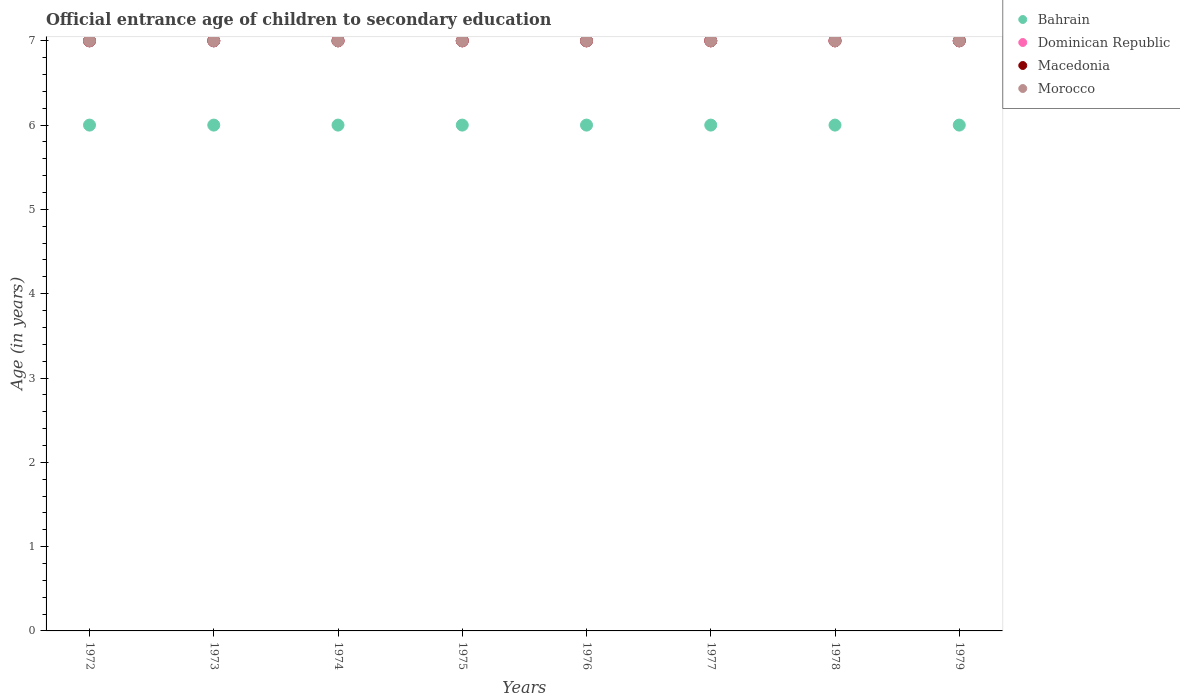Is the number of dotlines equal to the number of legend labels?
Your answer should be compact. Yes. What is the secondary school starting age of children in Dominican Republic in 1979?
Offer a terse response. 7. In which year was the secondary school starting age of children in Macedonia minimum?
Your answer should be very brief. 1972. What is the total secondary school starting age of children in Dominican Republic in the graph?
Ensure brevity in your answer.  56. What is the difference between the secondary school starting age of children in Bahrain in 1976 and that in 1978?
Provide a short and direct response. 0. What is the difference between the secondary school starting age of children in Dominican Republic in 1973 and the secondary school starting age of children in Macedonia in 1972?
Your answer should be compact. 0. What is the average secondary school starting age of children in Dominican Republic per year?
Make the answer very short. 7. In the year 1973, what is the difference between the secondary school starting age of children in Dominican Republic and secondary school starting age of children in Macedonia?
Provide a succinct answer. 0. What is the ratio of the secondary school starting age of children in Morocco in 1974 to that in 1979?
Offer a very short reply. 1. Is the secondary school starting age of children in Dominican Republic in 1978 less than that in 1979?
Provide a short and direct response. No. Is the difference between the secondary school starting age of children in Dominican Republic in 1972 and 1978 greater than the difference between the secondary school starting age of children in Macedonia in 1972 and 1978?
Give a very brief answer. No. What is the difference between the highest and the second highest secondary school starting age of children in Macedonia?
Make the answer very short. 0. Is it the case that in every year, the sum of the secondary school starting age of children in Bahrain and secondary school starting age of children in Morocco  is greater than the secondary school starting age of children in Macedonia?
Your answer should be compact. Yes. Is the secondary school starting age of children in Dominican Republic strictly greater than the secondary school starting age of children in Bahrain over the years?
Provide a short and direct response. Yes. How many dotlines are there?
Offer a terse response. 4. Does the graph contain any zero values?
Make the answer very short. No. Where does the legend appear in the graph?
Provide a short and direct response. Top right. What is the title of the graph?
Offer a very short reply. Official entrance age of children to secondary education. Does "Myanmar" appear as one of the legend labels in the graph?
Your answer should be compact. No. What is the label or title of the X-axis?
Your response must be concise. Years. What is the label or title of the Y-axis?
Provide a succinct answer. Age (in years). What is the Age (in years) in Bahrain in 1972?
Provide a short and direct response. 6. What is the Age (in years) in Dominican Republic in 1972?
Ensure brevity in your answer.  7. What is the Age (in years) of Morocco in 1972?
Offer a very short reply. 7. What is the Age (in years) of Bahrain in 1973?
Your response must be concise. 6. What is the Age (in years) in Bahrain in 1974?
Make the answer very short. 6. What is the Age (in years) of Dominican Republic in 1974?
Your answer should be compact. 7. What is the Age (in years) in Macedonia in 1974?
Keep it short and to the point. 7. What is the Age (in years) of Morocco in 1974?
Your answer should be very brief. 7. What is the Age (in years) in Bahrain in 1975?
Keep it short and to the point. 6. What is the Age (in years) of Macedonia in 1975?
Your answer should be compact. 7. What is the Age (in years) in Dominican Republic in 1976?
Offer a very short reply. 7. What is the Age (in years) in Dominican Republic in 1977?
Ensure brevity in your answer.  7. What is the Age (in years) of Macedonia in 1977?
Your response must be concise. 7. What is the Age (in years) in Morocco in 1977?
Make the answer very short. 7. What is the Age (in years) in Bahrain in 1978?
Offer a very short reply. 6. What is the Age (in years) of Dominican Republic in 1978?
Offer a terse response. 7. What is the Age (in years) of Bahrain in 1979?
Offer a terse response. 6. What is the Age (in years) of Macedonia in 1979?
Your answer should be very brief. 7. What is the Age (in years) in Morocco in 1979?
Keep it short and to the point. 7. Across all years, what is the maximum Age (in years) in Bahrain?
Your response must be concise. 6. Across all years, what is the maximum Age (in years) in Macedonia?
Provide a succinct answer. 7. Across all years, what is the maximum Age (in years) in Morocco?
Provide a succinct answer. 7. Across all years, what is the minimum Age (in years) of Bahrain?
Make the answer very short. 6. What is the total Age (in years) in Dominican Republic in the graph?
Offer a terse response. 56. What is the total Age (in years) of Macedonia in the graph?
Provide a succinct answer. 56. What is the difference between the Age (in years) in Bahrain in 1972 and that in 1973?
Provide a succinct answer. 0. What is the difference between the Age (in years) in Macedonia in 1972 and that in 1973?
Offer a very short reply. 0. What is the difference between the Age (in years) of Morocco in 1972 and that in 1973?
Offer a very short reply. 0. What is the difference between the Age (in years) of Macedonia in 1972 and that in 1974?
Make the answer very short. 0. What is the difference between the Age (in years) in Morocco in 1972 and that in 1974?
Ensure brevity in your answer.  0. What is the difference between the Age (in years) in Morocco in 1972 and that in 1975?
Keep it short and to the point. 0. What is the difference between the Age (in years) of Macedonia in 1972 and that in 1976?
Provide a short and direct response. 0. What is the difference between the Age (in years) of Macedonia in 1972 and that in 1977?
Offer a terse response. 0. What is the difference between the Age (in years) in Bahrain in 1972 and that in 1978?
Ensure brevity in your answer.  0. What is the difference between the Age (in years) in Macedonia in 1972 and that in 1978?
Offer a terse response. 0. What is the difference between the Age (in years) of Morocco in 1972 and that in 1978?
Offer a terse response. 0. What is the difference between the Age (in years) in Bahrain in 1973 and that in 1974?
Your answer should be very brief. 0. What is the difference between the Age (in years) in Dominican Republic in 1973 and that in 1974?
Offer a terse response. 0. What is the difference between the Age (in years) of Macedonia in 1973 and that in 1974?
Your answer should be very brief. 0. What is the difference between the Age (in years) in Morocco in 1973 and that in 1974?
Offer a terse response. 0. What is the difference between the Age (in years) in Dominican Republic in 1973 and that in 1975?
Ensure brevity in your answer.  0. What is the difference between the Age (in years) of Bahrain in 1973 and that in 1976?
Offer a very short reply. 0. What is the difference between the Age (in years) of Dominican Republic in 1973 and that in 1976?
Offer a very short reply. 0. What is the difference between the Age (in years) in Macedonia in 1973 and that in 1976?
Offer a terse response. 0. What is the difference between the Age (in years) of Morocco in 1973 and that in 1976?
Offer a very short reply. 0. What is the difference between the Age (in years) in Bahrain in 1973 and that in 1978?
Your answer should be compact. 0. What is the difference between the Age (in years) in Dominican Republic in 1973 and that in 1978?
Offer a terse response. 0. What is the difference between the Age (in years) of Macedonia in 1973 and that in 1978?
Your answer should be compact. 0. What is the difference between the Age (in years) of Bahrain in 1973 and that in 1979?
Provide a succinct answer. 0. What is the difference between the Age (in years) in Bahrain in 1974 and that in 1975?
Your response must be concise. 0. What is the difference between the Age (in years) of Bahrain in 1974 and that in 1976?
Your answer should be very brief. 0. What is the difference between the Age (in years) in Dominican Republic in 1974 and that in 1976?
Your answer should be very brief. 0. What is the difference between the Age (in years) in Dominican Republic in 1974 and that in 1977?
Your answer should be compact. 0. What is the difference between the Age (in years) of Morocco in 1974 and that in 1977?
Keep it short and to the point. 0. What is the difference between the Age (in years) in Bahrain in 1974 and that in 1978?
Make the answer very short. 0. What is the difference between the Age (in years) in Dominican Republic in 1974 and that in 1978?
Ensure brevity in your answer.  0. What is the difference between the Age (in years) of Morocco in 1974 and that in 1978?
Your response must be concise. 0. What is the difference between the Age (in years) of Dominican Republic in 1975 and that in 1976?
Your answer should be compact. 0. What is the difference between the Age (in years) in Bahrain in 1975 and that in 1978?
Ensure brevity in your answer.  0. What is the difference between the Age (in years) of Dominican Republic in 1975 and that in 1978?
Offer a terse response. 0. What is the difference between the Age (in years) in Morocco in 1975 and that in 1978?
Make the answer very short. 0. What is the difference between the Age (in years) of Bahrain in 1975 and that in 1979?
Make the answer very short. 0. What is the difference between the Age (in years) of Morocco in 1975 and that in 1979?
Keep it short and to the point. 0. What is the difference between the Age (in years) in Dominican Republic in 1976 and that in 1977?
Give a very brief answer. 0. What is the difference between the Age (in years) of Bahrain in 1976 and that in 1978?
Offer a terse response. 0. What is the difference between the Age (in years) in Bahrain in 1976 and that in 1979?
Provide a succinct answer. 0. What is the difference between the Age (in years) in Morocco in 1976 and that in 1979?
Keep it short and to the point. 0. What is the difference between the Age (in years) of Bahrain in 1977 and that in 1978?
Your response must be concise. 0. What is the difference between the Age (in years) of Dominican Republic in 1977 and that in 1978?
Provide a short and direct response. 0. What is the difference between the Age (in years) of Macedonia in 1977 and that in 1978?
Your answer should be very brief. 0. What is the difference between the Age (in years) of Morocco in 1977 and that in 1978?
Ensure brevity in your answer.  0. What is the difference between the Age (in years) in Bahrain in 1977 and that in 1979?
Provide a succinct answer. 0. What is the difference between the Age (in years) of Morocco in 1977 and that in 1979?
Give a very brief answer. 0. What is the difference between the Age (in years) of Bahrain in 1978 and that in 1979?
Keep it short and to the point. 0. What is the difference between the Age (in years) of Dominican Republic in 1978 and that in 1979?
Provide a short and direct response. 0. What is the difference between the Age (in years) in Macedonia in 1978 and that in 1979?
Make the answer very short. 0. What is the difference between the Age (in years) in Morocco in 1978 and that in 1979?
Offer a very short reply. 0. What is the difference between the Age (in years) in Bahrain in 1972 and the Age (in years) in Macedonia in 1973?
Ensure brevity in your answer.  -1. What is the difference between the Age (in years) of Bahrain in 1972 and the Age (in years) of Morocco in 1973?
Provide a short and direct response. -1. What is the difference between the Age (in years) in Dominican Republic in 1972 and the Age (in years) in Macedonia in 1973?
Your response must be concise. 0. What is the difference between the Age (in years) in Dominican Republic in 1972 and the Age (in years) in Morocco in 1973?
Your response must be concise. 0. What is the difference between the Age (in years) of Macedonia in 1972 and the Age (in years) of Morocco in 1973?
Your answer should be compact. 0. What is the difference between the Age (in years) of Bahrain in 1972 and the Age (in years) of Dominican Republic in 1974?
Give a very brief answer. -1. What is the difference between the Age (in years) in Bahrain in 1972 and the Age (in years) in Macedonia in 1974?
Provide a short and direct response. -1. What is the difference between the Age (in years) of Dominican Republic in 1972 and the Age (in years) of Morocco in 1974?
Offer a very short reply. 0. What is the difference between the Age (in years) of Macedonia in 1972 and the Age (in years) of Morocco in 1974?
Provide a succinct answer. 0. What is the difference between the Age (in years) of Bahrain in 1972 and the Age (in years) of Dominican Republic in 1975?
Keep it short and to the point. -1. What is the difference between the Age (in years) of Bahrain in 1972 and the Age (in years) of Macedonia in 1975?
Make the answer very short. -1. What is the difference between the Age (in years) in Bahrain in 1972 and the Age (in years) in Morocco in 1975?
Provide a succinct answer. -1. What is the difference between the Age (in years) of Dominican Republic in 1972 and the Age (in years) of Morocco in 1975?
Provide a short and direct response. 0. What is the difference between the Age (in years) in Macedonia in 1972 and the Age (in years) in Morocco in 1975?
Offer a very short reply. 0. What is the difference between the Age (in years) in Bahrain in 1972 and the Age (in years) in Macedonia in 1976?
Make the answer very short. -1. What is the difference between the Age (in years) in Bahrain in 1972 and the Age (in years) in Morocco in 1976?
Provide a succinct answer. -1. What is the difference between the Age (in years) in Dominican Republic in 1972 and the Age (in years) in Macedonia in 1976?
Your answer should be very brief. 0. What is the difference between the Age (in years) of Macedonia in 1972 and the Age (in years) of Morocco in 1976?
Give a very brief answer. 0. What is the difference between the Age (in years) of Macedonia in 1972 and the Age (in years) of Morocco in 1977?
Make the answer very short. 0. What is the difference between the Age (in years) of Bahrain in 1972 and the Age (in years) of Macedonia in 1978?
Provide a short and direct response. -1. What is the difference between the Age (in years) of Dominican Republic in 1972 and the Age (in years) of Macedonia in 1978?
Make the answer very short. 0. What is the difference between the Age (in years) in Dominican Republic in 1972 and the Age (in years) in Morocco in 1978?
Ensure brevity in your answer.  0. What is the difference between the Age (in years) in Macedonia in 1972 and the Age (in years) in Morocco in 1978?
Offer a very short reply. 0. What is the difference between the Age (in years) in Bahrain in 1972 and the Age (in years) in Dominican Republic in 1979?
Your answer should be very brief. -1. What is the difference between the Age (in years) of Dominican Republic in 1972 and the Age (in years) of Morocco in 1979?
Ensure brevity in your answer.  0. What is the difference between the Age (in years) of Macedonia in 1972 and the Age (in years) of Morocco in 1979?
Offer a terse response. 0. What is the difference between the Age (in years) in Bahrain in 1973 and the Age (in years) in Dominican Republic in 1974?
Your answer should be very brief. -1. What is the difference between the Age (in years) of Bahrain in 1973 and the Age (in years) of Morocco in 1974?
Make the answer very short. -1. What is the difference between the Age (in years) of Dominican Republic in 1973 and the Age (in years) of Macedonia in 1974?
Ensure brevity in your answer.  0. What is the difference between the Age (in years) in Dominican Republic in 1973 and the Age (in years) in Morocco in 1974?
Offer a terse response. 0. What is the difference between the Age (in years) in Macedonia in 1973 and the Age (in years) in Morocco in 1974?
Give a very brief answer. 0. What is the difference between the Age (in years) of Bahrain in 1973 and the Age (in years) of Dominican Republic in 1975?
Offer a very short reply. -1. What is the difference between the Age (in years) of Bahrain in 1973 and the Age (in years) of Macedonia in 1975?
Your answer should be very brief. -1. What is the difference between the Age (in years) in Macedonia in 1973 and the Age (in years) in Morocco in 1975?
Your answer should be very brief. 0. What is the difference between the Age (in years) in Bahrain in 1973 and the Age (in years) in Dominican Republic in 1976?
Offer a terse response. -1. What is the difference between the Age (in years) in Bahrain in 1973 and the Age (in years) in Macedonia in 1976?
Your response must be concise. -1. What is the difference between the Age (in years) of Bahrain in 1973 and the Age (in years) of Morocco in 1976?
Offer a terse response. -1. What is the difference between the Age (in years) of Dominican Republic in 1973 and the Age (in years) of Macedonia in 1976?
Your answer should be very brief. 0. What is the difference between the Age (in years) of Macedonia in 1973 and the Age (in years) of Morocco in 1976?
Provide a succinct answer. 0. What is the difference between the Age (in years) in Bahrain in 1973 and the Age (in years) in Dominican Republic in 1977?
Give a very brief answer. -1. What is the difference between the Age (in years) in Bahrain in 1973 and the Age (in years) in Morocco in 1977?
Keep it short and to the point. -1. What is the difference between the Age (in years) in Dominican Republic in 1973 and the Age (in years) in Macedonia in 1977?
Provide a short and direct response. 0. What is the difference between the Age (in years) of Dominican Republic in 1973 and the Age (in years) of Macedonia in 1978?
Offer a very short reply. 0. What is the difference between the Age (in years) in Dominican Republic in 1973 and the Age (in years) in Morocco in 1978?
Make the answer very short. 0. What is the difference between the Age (in years) in Macedonia in 1973 and the Age (in years) in Morocco in 1978?
Your answer should be very brief. 0. What is the difference between the Age (in years) of Bahrain in 1973 and the Age (in years) of Dominican Republic in 1979?
Provide a short and direct response. -1. What is the difference between the Age (in years) in Bahrain in 1973 and the Age (in years) in Morocco in 1979?
Your response must be concise. -1. What is the difference between the Age (in years) of Dominican Republic in 1973 and the Age (in years) of Macedonia in 1979?
Give a very brief answer. 0. What is the difference between the Age (in years) in Dominican Republic in 1973 and the Age (in years) in Morocco in 1979?
Your answer should be very brief. 0. What is the difference between the Age (in years) in Bahrain in 1974 and the Age (in years) in Dominican Republic in 1975?
Provide a succinct answer. -1. What is the difference between the Age (in years) of Bahrain in 1974 and the Age (in years) of Morocco in 1975?
Your response must be concise. -1. What is the difference between the Age (in years) of Dominican Republic in 1974 and the Age (in years) of Macedonia in 1975?
Give a very brief answer. 0. What is the difference between the Age (in years) in Dominican Republic in 1974 and the Age (in years) in Morocco in 1975?
Offer a terse response. 0. What is the difference between the Age (in years) of Macedonia in 1974 and the Age (in years) of Morocco in 1975?
Offer a terse response. 0. What is the difference between the Age (in years) in Bahrain in 1974 and the Age (in years) in Dominican Republic in 1976?
Your answer should be very brief. -1. What is the difference between the Age (in years) of Dominican Republic in 1974 and the Age (in years) of Macedonia in 1976?
Offer a very short reply. 0. What is the difference between the Age (in years) of Dominican Republic in 1974 and the Age (in years) of Morocco in 1976?
Your answer should be very brief. 0. What is the difference between the Age (in years) of Macedonia in 1974 and the Age (in years) of Morocco in 1976?
Keep it short and to the point. 0. What is the difference between the Age (in years) in Bahrain in 1974 and the Age (in years) in Macedonia in 1978?
Provide a succinct answer. -1. What is the difference between the Age (in years) in Bahrain in 1974 and the Age (in years) in Morocco in 1978?
Ensure brevity in your answer.  -1. What is the difference between the Age (in years) in Dominican Republic in 1974 and the Age (in years) in Macedonia in 1978?
Keep it short and to the point. 0. What is the difference between the Age (in years) of Dominican Republic in 1974 and the Age (in years) of Morocco in 1978?
Keep it short and to the point. 0. What is the difference between the Age (in years) of Macedonia in 1974 and the Age (in years) of Morocco in 1979?
Keep it short and to the point. 0. What is the difference between the Age (in years) in Bahrain in 1975 and the Age (in years) in Macedonia in 1976?
Your response must be concise. -1. What is the difference between the Age (in years) of Dominican Republic in 1975 and the Age (in years) of Macedonia in 1976?
Give a very brief answer. 0. What is the difference between the Age (in years) in Dominican Republic in 1975 and the Age (in years) in Morocco in 1976?
Provide a short and direct response. 0. What is the difference between the Age (in years) of Macedonia in 1975 and the Age (in years) of Morocco in 1976?
Your response must be concise. 0. What is the difference between the Age (in years) in Bahrain in 1975 and the Age (in years) in Dominican Republic in 1977?
Your answer should be compact. -1. What is the difference between the Age (in years) of Bahrain in 1975 and the Age (in years) of Morocco in 1977?
Offer a very short reply. -1. What is the difference between the Age (in years) of Dominican Republic in 1975 and the Age (in years) of Macedonia in 1977?
Your answer should be very brief. 0. What is the difference between the Age (in years) of Dominican Republic in 1975 and the Age (in years) of Morocco in 1977?
Your answer should be very brief. 0. What is the difference between the Age (in years) of Macedonia in 1975 and the Age (in years) of Morocco in 1977?
Offer a very short reply. 0. What is the difference between the Age (in years) in Bahrain in 1975 and the Age (in years) in Dominican Republic in 1978?
Provide a succinct answer. -1. What is the difference between the Age (in years) in Dominican Republic in 1975 and the Age (in years) in Macedonia in 1978?
Keep it short and to the point. 0. What is the difference between the Age (in years) in Dominican Republic in 1975 and the Age (in years) in Morocco in 1978?
Your answer should be very brief. 0. What is the difference between the Age (in years) of Bahrain in 1975 and the Age (in years) of Dominican Republic in 1979?
Keep it short and to the point. -1. What is the difference between the Age (in years) in Bahrain in 1975 and the Age (in years) in Morocco in 1979?
Keep it short and to the point. -1. What is the difference between the Age (in years) of Dominican Republic in 1975 and the Age (in years) of Macedonia in 1979?
Give a very brief answer. 0. What is the difference between the Age (in years) of Dominican Republic in 1975 and the Age (in years) of Morocco in 1979?
Make the answer very short. 0. What is the difference between the Age (in years) in Macedonia in 1975 and the Age (in years) in Morocco in 1979?
Your answer should be very brief. 0. What is the difference between the Age (in years) of Bahrain in 1976 and the Age (in years) of Macedonia in 1977?
Provide a short and direct response. -1. What is the difference between the Age (in years) of Dominican Republic in 1976 and the Age (in years) of Macedonia in 1977?
Offer a terse response. 0. What is the difference between the Age (in years) in Dominican Republic in 1976 and the Age (in years) in Morocco in 1977?
Your answer should be compact. 0. What is the difference between the Age (in years) of Macedonia in 1976 and the Age (in years) of Morocco in 1977?
Your answer should be compact. 0. What is the difference between the Age (in years) in Bahrain in 1976 and the Age (in years) in Morocco in 1978?
Provide a short and direct response. -1. What is the difference between the Age (in years) in Bahrain in 1976 and the Age (in years) in Dominican Republic in 1979?
Provide a short and direct response. -1. What is the difference between the Age (in years) of Macedonia in 1976 and the Age (in years) of Morocco in 1979?
Give a very brief answer. 0. What is the difference between the Age (in years) in Bahrain in 1977 and the Age (in years) in Macedonia in 1978?
Ensure brevity in your answer.  -1. What is the difference between the Age (in years) of Bahrain in 1977 and the Age (in years) of Morocco in 1978?
Ensure brevity in your answer.  -1. What is the difference between the Age (in years) in Dominican Republic in 1977 and the Age (in years) in Macedonia in 1978?
Offer a very short reply. 0. What is the difference between the Age (in years) of Bahrain in 1977 and the Age (in years) of Dominican Republic in 1979?
Ensure brevity in your answer.  -1. What is the difference between the Age (in years) in Dominican Republic in 1977 and the Age (in years) in Morocco in 1979?
Make the answer very short. 0. What is the difference between the Age (in years) in Bahrain in 1978 and the Age (in years) in Dominican Republic in 1979?
Make the answer very short. -1. What is the difference between the Age (in years) in Bahrain in 1978 and the Age (in years) in Morocco in 1979?
Your answer should be very brief. -1. What is the average Age (in years) in Bahrain per year?
Provide a short and direct response. 6. What is the average Age (in years) in Dominican Republic per year?
Your answer should be compact. 7. What is the average Age (in years) of Macedonia per year?
Your answer should be very brief. 7. In the year 1972, what is the difference between the Age (in years) in Bahrain and Age (in years) in Dominican Republic?
Offer a very short reply. -1. In the year 1972, what is the difference between the Age (in years) in Bahrain and Age (in years) in Macedonia?
Offer a terse response. -1. In the year 1972, what is the difference between the Age (in years) of Dominican Republic and Age (in years) of Macedonia?
Ensure brevity in your answer.  0. In the year 1972, what is the difference between the Age (in years) of Dominican Republic and Age (in years) of Morocco?
Make the answer very short. 0. In the year 1973, what is the difference between the Age (in years) in Macedonia and Age (in years) in Morocco?
Give a very brief answer. 0. In the year 1974, what is the difference between the Age (in years) in Bahrain and Age (in years) in Dominican Republic?
Your response must be concise. -1. In the year 1974, what is the difference between the Age (in years) in Bahrain and Age (in years) in Macedonia?
Provide a succinct answer. -1. In the year 1975, what is the difference between the Age (in years) in Bahrain and Age (in years) in Dominican Republic?
Offer a very short reply. -1. In the year 1975, what is the difference between the Age (in years) in Bahrain and Age (in years) in Morocco?
Your response must be concise. -1. In the year 1975, what is the difference between the Age (in years) in Dominican Republic and Age (in years) in Macedonia?
Make the answer very short. 0. In the year 1975, what is the difference between the Age (in years) in Dominican Republic and Age (in years) in Morocco?
Keep it short and to the point. 0. In the year 1976, what is the difference between the Age (in years) of Bahrain and Age (in years) of Dominican Republic?
Keep it short and to the point. -1. In the year 1976, what is the difference between the Age (in years) of Bahrain and Age (in years) of Morocco?
Give a very brief answer. -1. In the year 1976, what is the difference between the Age (in years) of Dominican Republic and Age (in years) of Macedonia?
Your answer should be very brief. 0. In the year 1976, what is the difference between the Age (in years) in Dominican Republic and Age (in years) in Morocco?
Offer a very short reply. 0. In the year 1976, what is the difference between the Age (in years) of Macedonia and Age (in years) of Morocco?
Offer a terse response. 0. In the year 1977, what is the difference between the Age (in years) of Bahrain and Age (in years) of Dominican Republic?
Offer a very short reply. -1. In the year 1977, what is the difference between the Age (in years) in Dominican Republic and Age (in years) in Macedonia?
Provide a succinct answer. 0. In the year 1977, what is the difference between the Age (in years) of Dominican Republic and Age (in years) of Morocco?
Give a very brief answer. 0. In the year 1977, what is the difference between the Age (in years) of Macedonia and Age (in years) of Morocco?
Offer a terse response. 0. In the year 1978, what is the difference between the Age (in years) of Bahrain and Age (in years) of Dominican Republic?
Keep it short and to the point. -1. In the year 1978, what is the difference between the Age (in years) of Bahrain and Age (in years) of Morocco?
Provide a succinct answer. -1. In the year 1978, what is the difference between the Age (in years) of Dominican Republic and Age (in years) of Macedonia?
Ensure brevity in your answer.  0. In the year 1978, what is the difference between the Age (in years) in Dominican Republic and Age (in years) in Morocco?
Provide a short and direct response. 0. In the year 1978, what is the difference between the Age (in years) in Macedonia and Age (in years) in Morocco?
Give a very brief answer. 0. In the year 1979, what is the difference between the Age (in years) in Bahrain and Age (in years) in Macedonia?
Give a very brief answer. -1. In the year 1979, what is the difference between the Age (in years) in Dominican Republic and Age (in years) in Macedonia?
Make the answer very short. 0. In the year 1979, what is the difference between the Age (in years) in Macedonia and Age (in years) in Morocco?
Provide a succinct answer. 0. What is the ratio of the Age (in years) in Bahrain in 1972 to that in 1973?
Offer a terse response. 1. What is the ratio of the Age (in years) in Macedonia in 1972 to that in 1973?
Keep it short and to the point. 1. What is the ratio of the Age (in years) in Bahrain in 1972 to that in 1974?
Your answer should be compact. 1. What is the ratio of the Age (in years) of Macedonia in 1972 to that in 1974?
Give a very brief answer. 1. What is the ratio of the Age (in years) in Morocco in 1972 to that in 1974?
Ensure brevity in your answer.  1. What is the ratio of the Age (in years) of Bahrain in 1972 to that in 1975?
Your answer should be compact. 1. What is the ratio of the Age (in years) of Dominican Republic in 1972 to that in 1975?
Keep it short and to the point. 1. What is the ratio of the Age (in years) of Macedonia in 1972 to that in 1975?
Your answer should be compact. 1. What is the ratio of the Age (in years) in Morocco in 1972 to that in 1975?
Your answer should be very brief. 1. What is the ratio of the Age (in years) of Macedonia in 1972 to that in 1976?
Your answer should be very brief. 1. What is the ratio of the Age (in years) of Bahrain in 1972 to that in 1977?
Offer a terse response. 1. What is the ratio of the Age (in years) in Macedonia in 1972 to that in 1977?
Make the answer very short. 1. What is the ratio of the Age (in years) of Bahrain in 1972 to that in 1978?
Provide a succinct answer. 1. What is the ratio of the Age (in years) of Bahrain in 1972 to that in 1979?
Give a very brief answer. 1. What is the ratio of the Age (in years) of Bahrain in 1973 to that in 1974?
Provide a short and direct response. 1. What is the ratio of the Age (in years) of Morocco in 1973 to that in 1974?
Offer a very short reply. 1. What is the ratio of the Age (in years) in Dominican Republic in 1973 to that in 1975?
Give a very brief answer. 1. What is the ratio of the Age (in years) in Macedonia in 1973 to that in 1975?
Give a very brief answer. 1. What is the ratio of the Age (in years) in Morocco in 1973 to that in 1975?
Ensure brevity in your answer.  1. What is the ratio of the Age (in years) of Bahrain in 1973 to that in 1977?
Your answer should be very brief. 1. What is the ratio of the Age (in years) in Dominican Republic in 1973 to that in 1977?
Your answer should be compact. 1. What is the ratio of the Age (in years) of Macedonia in 1973 to that in 1977?
Provide a short and direct response. 1. What is the ratio of the Age (in years) in Dominican Republic in 1973 to that in 1978?
Ensure brevity in your answer.  1. What is the ratio of the Age (in years) of Macedonia in 1973 to that in 1978?
Make the answer very short. 1. What is the ratio of the Age (in years) of Dominican Republic in 1973 to that in 1979?
Give a very brief answer. 1. What is the ratio of the Age (in years) in Morocco in 1973 to that in 1979?
Keep it short and to the point. 1. What is the ratio of the Age (in years) in Dominican Republic in 1974 to that in 1975?
Keep it short and to the point. 1. What is the ratio of the Age (in years) of Macedonia in 1974 to that in 1975?
Provide a succinct answer. 1. What is the ratio of the Age (in years) of Bahrain in 1974 to that in 1976?
Give a very brief answer. 1. What is the ratio of the Age (in years) of Bahrain in 1974 to that in 1977?
Your response must be concise. 1. What is the ratio of the Age (in years) in Morocco in 1974 to that in 1977?
Offer a terse response. 1. What is the ratio of the Age (in years) of Bahrain in 1974 to that in 1978?
Provide a short and direct response. 1. What is the ratio of the Age (in years) in Dominican Republic in 1974 to that in 1978?
Give a very brief answer. 1. What is the ratio of the Age (in years) of Macedonia in 1974 to that in 1978?
Make the answer very short. 1. What is the ratio of the Age (in years) of Dominican Republic in 1974 to that in 1979?
Keep it short and to the point. 1. What is the ratio of the Age (in years) in Macedonia in 1974 to that in 1979?
Provide a succinct answer. 1. What is the ratio of the Age (in years) of Morocco in 1974 to that in 1979?
Give a very brief answer. 1. What is the ratio of the Age (in years) of Macedonia in 1975 to that in 1976?
Offer a very short reply. 1. What is the ratio of the Age (in years) in Dominican Republic in 1975 to that in 1977?
Ensure brevity in your answer.  1. What is the ratio of the Age (in years) in Morocco in 1975 to that in 1977?
Make the answer very short. 1. What is the ratio of the Age (in years) in Macedonia in 1975 to that in 1978?
Your answer should be compact. 1. What is the ratio of the Age (in years) of Morocco in 1975 to that in 1978?
Offer a terse response. 1. What is the ratio of the Age (in years) in Bahrain in 1975 to that in 1979?
Give a very brief answer. 1. What is the ratio of the Age (in years) of Macedonia in 1975 to that in 1979?
Offer a terse response. 1. What is the ratio of the Age (in years) in Morocco in 1975 to that in 1979?
Make the answer very short. 1. What is the ratio of the Age (in years) in Dominican Republic in 1976 to that in 1977?
Your answer should be compact. 1. What is the ratio of the Age (in years) of Macedonia in 1976 to that in 1978?
Provide a succinct answer. 1. What is the ratio of the Age (in years) in Bahrain in 1976 to that in 1979?
Offer a very short reply. 1. What is the ratio of the Age (in years) in Dominican Republic in 1976 to that in 1979?
Your answer should be very brief. 1. What is the ratio of the Age (in years) in Morocco in 1976 to that in 1979?
Your response must be concise. 1. What is the ratio of the Age (in years) of Bahrain in 1977 to that in 1978?
Make the answer very short. 1. What is the ratio of the Age (in years) in Dominican Republic in 1977 to that in 1978?
Your answer should be very brief. 1. What is the ratio of the Age (in years) of Macedonia in 1977 to that in 1978?
Offer a terse response. 1. What is the ratio of the Age (in years) in Morocco in 1977 to that in 1978?
Provide a short and direct response. 1. What is the ratio of the Age (in years) of Bahrain in 1977 to that in 1979?
Provide a short and direct response. 1. What is the ratio of the Age (in years) of Dominican Republic in 1977 to that in 1979?
Provide a succinct answer. 1. What is the ratio of the Age (in years) of Macedonia in 1977 to that in 1979?
Offer a terse response. 1. What is the ratio of the Age (in years) of Dominican Republic in 1978 to that in 1979?
Give a very brief answer. 1. What is the difference between the highest and the second highest Age (in years) in Dominican Republic?
Your answer should be compact. 0. What is the difference between the highest and the lowest Age (in years) in Macedonia?
Provide a succinct answer. 0. What is the difference between the highest and the lowest Age (in years) in Morocco?
Your response must be concise. 0. 